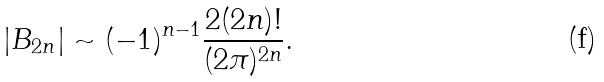Convert formula to latex. <formula><loc_0><loc_0><loc_500><loc_500>| B _ { 2 n } | \sim ( - 1 ) ^ { n - 1 } \frac { 2 ( 2 n ) ! } { ( 2 \pi ) ^ { 2 n } } .</formula> 